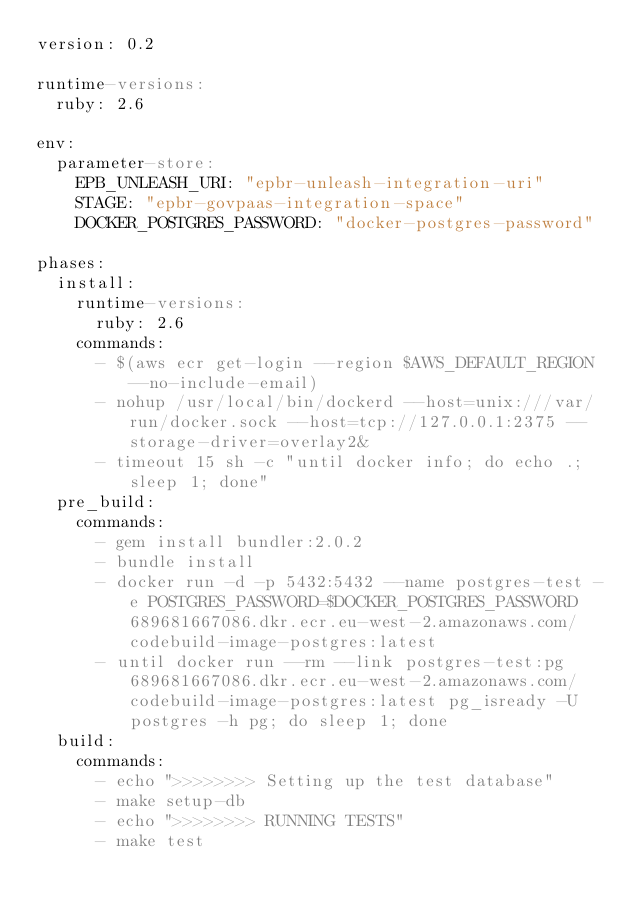Convert code to text. <code><loc_0><loc_0><loc_500><loc_500><_YAML_>version: 0.2

runtime-versions:
  ruby: 2.6

env:
  parameter-store:
    EPB_UNLEASH_URI: "epbr-unleash-integration-uri"
    STAGE: "epbr-govpaas-integration-space"
    DOCKER_POSTGRES_PASSWORD: "docker-postgres-password"

phases:
  install:
    runtime-versions:
      ruby: 2.6
    commands:
      - $(aws ecr get-login --region $AWS_DEFAULT_REGION --no-include-email)
      - nohup /usr/local/bin/dockerd --host=unix:///var/run/docker.sock --host=tcp://127.0.0.1:2375 --storage-driver=overlay2&
      - timeout 15 sh -c "until docker info; do echo .; sleep 1; done"
  pre_build:
    commands:
      - gem install bundler:2.0.2
      - bundle install
      - docker run -d -p 5432:5432 --name postgres-test -e POSTGRES_PASSWORD=$DOCKER_POSTGRES_PASSWORD 689681667086.dkr.ecr.eu-west-2.amazonaws.com/codebuild-image-postgres:latest
      - until docker run --rm --link postgres-test:pg 689681667086.dkr.ecr.eu-west-2.amazonaws.com/codebuild-image-postgres:latest pg_isready -U postgres -h pg; do sleep 1; done
  build:
    commands:
      - echo ">>>>>>>> Setting up the test database"
      - make setup-db
      - echo ">>>>>>>> RUNNING TESTS"
      - make test
</code> 